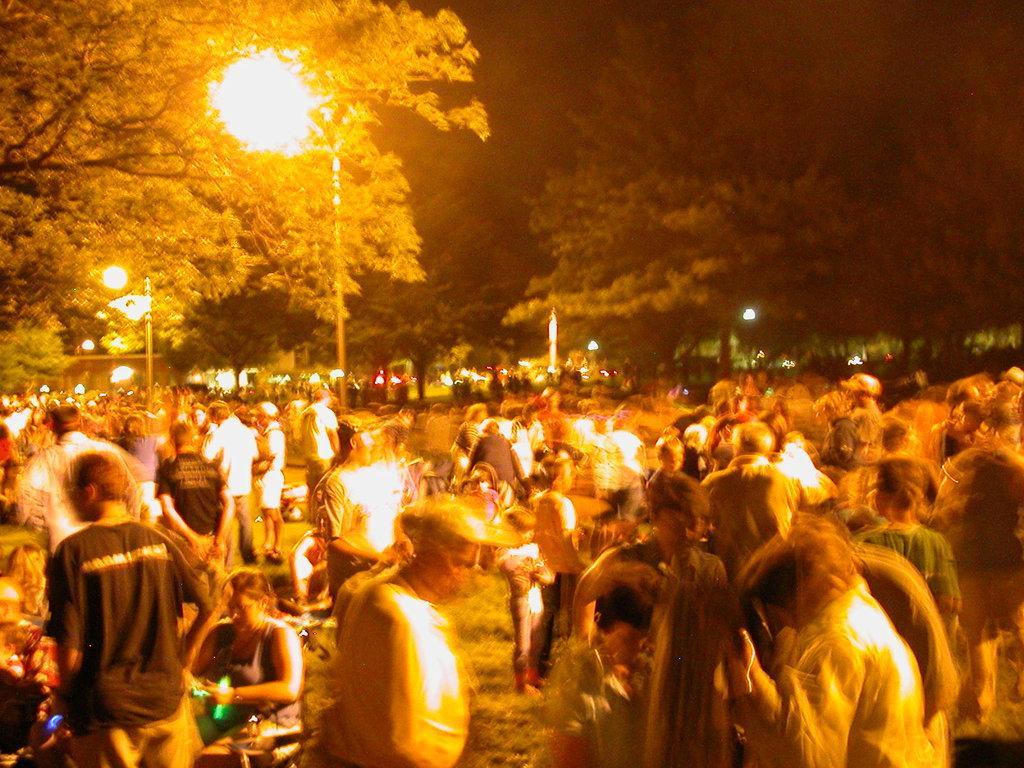Describe this image in one or two sentences. In this picture there are many people waiting in the ground. Behind there is a street light and huge trees. 